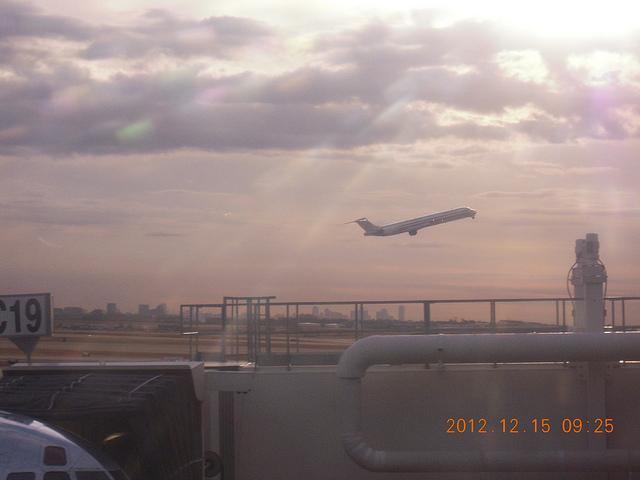Are any of these plane moving?
Short answer required. Yes. What is traveling over the highway?
Give a very brief answer. Plane. What date was the picture taken?
Answer briefly. 12/15/2012. Is this plane taking off?
Give a very brief answer. Yes. Is the plane taking off or landing?
Quick response, please. Taking off. Is the landing gear down?
Be succinct. No. 